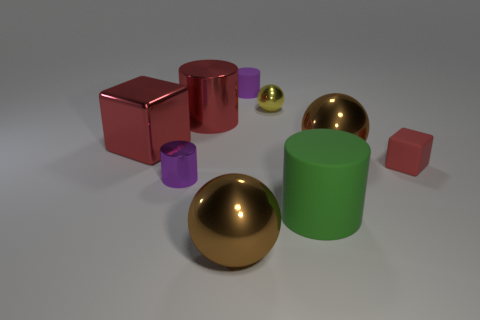Subtract all large balls. How many balls are left? 1 Subtract all red cylinders. How many cylinders are left? 3 Subtract all blue cylinders. Subtract all brown cubes. How many cylinders are left? 4 Subtract all blocks. How many objects are left? 7 Add 7 shiny cylinders. How many shiny cylinders exist? 9 Subtract 1 red blocks. How many objects are left? 8 Subtract all small metal objects. Subtract all gray matte cylinders. How many objects are left? 7 Add 1 purple rubber cylinders. How many purple rubber cylinders are left? 2 